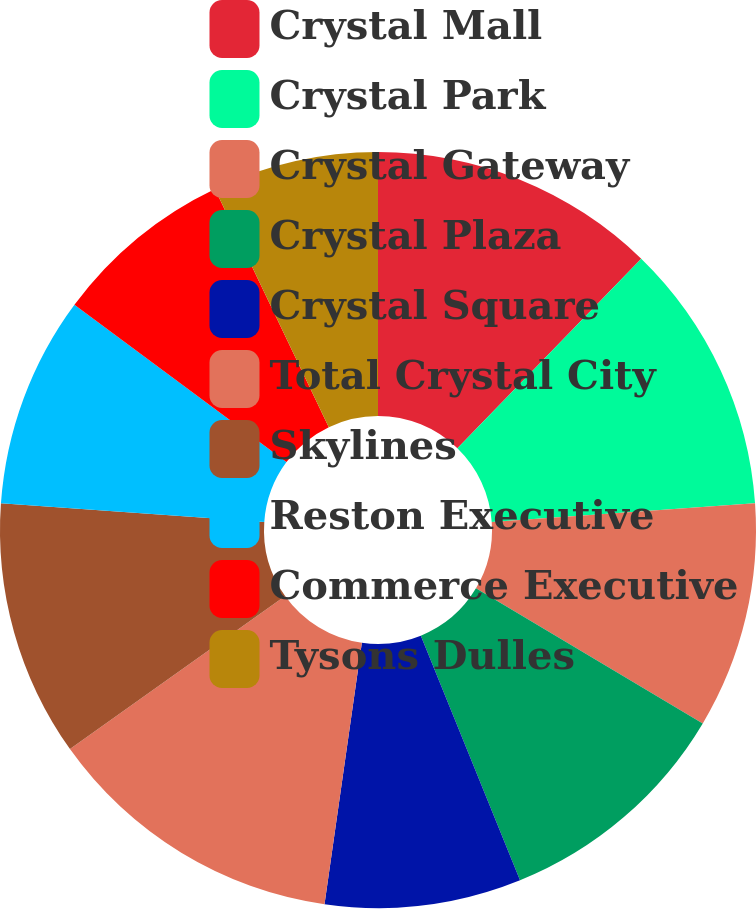Convert chart to OTSL. <chart><loc_0><loc_0><loc_500><loc_500><pie_chart><fcel>Crystal Mall<fcel>Crystal Park<fcel>Crystal Gateway<fcel>Crystal Plaza<fcel>Crystal Square<fcel>Total Crystal City<fcel>Skylines<fcel>Reston Executive<fcel>Commerce Executive<fcel>Tysons Dulles<nl><fcel>12.26%<fcel>11.61%<fcel>9.68%<fcel>10.32%<fcel>8.39%<fcel>12.9%<fcel>10.97%<fcel>9.03%<fcel>7.74%<fcel>7.1%<nl></chart> 